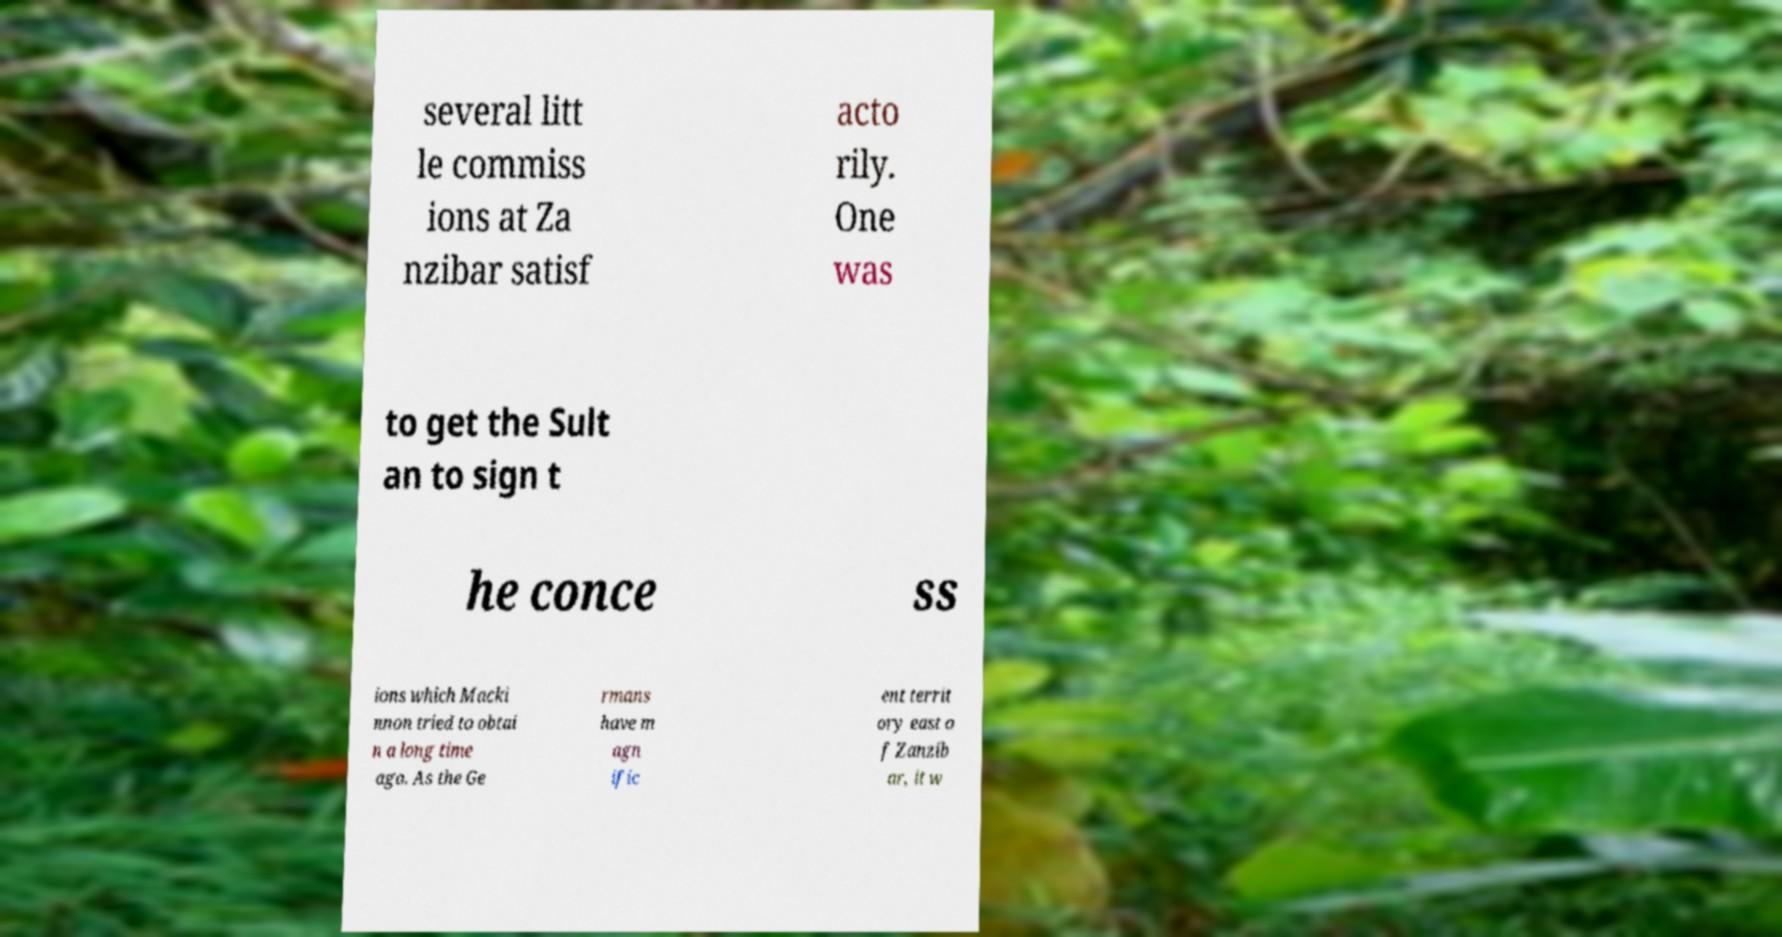Please identify and transcribe the text found in this image. several litt le commiss ions at Za nzibar satisf acto rily. One was to get the Sult an to sign t he conce ss ions which Macki nnon tried to obtai n a long time ago. As the Ge rmans have m agn ific ent territ ory east o f Zanzib ar, it w 